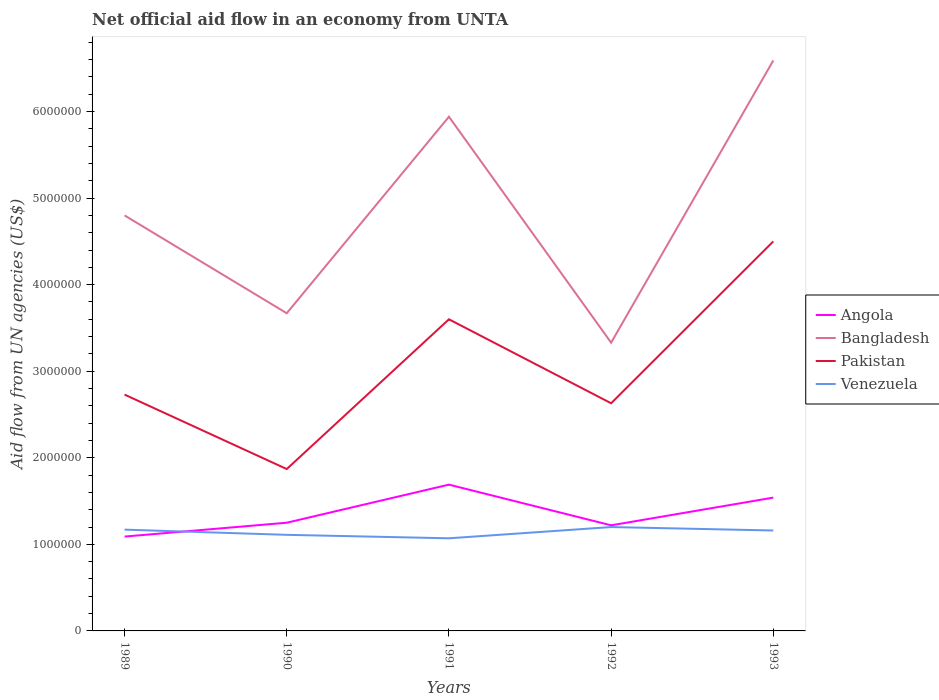Across all years, what is the maximum net official aid flow in Bangladesh?
Offer a terse response. 3.33e+06. In which year was the net official aid flow in Bangladesh maximum?
Keep it short and to the point. 1992. What is the total net official aid flow in Venezuela in the graph?
Make the answer very short. 4.00e+04. What is the difference between the highest and the second highest net official aid flow in Pakistan?
Your answer should be compact. 2.63e+06. What is the difference between the highest and the lowest net official aid flow in Venezuela?
Give a very brief answer. 3. Is the net official aid flow in Bangladesh strictly greater than the net official aid flow in Angola over the years?
Your answer should be very brief. No. How many lines are there?
Your response must be concise. 4. How many years are there in the graph?
Offer a terse response. 5. Does the graph contain any zero values?
Provide a short and direct response. No. Does the graph contain grids?
Ensure brevity in your answer.  No. Where does the legend appear in the graph?
Provide a short and direct response. Center right. What is the title of the graph?
Make the answer very short. Net official aid flow in an economy from UNTA. What is the label or title of the Y-axis?
Make the answer very short. Aid flow from UN agencies (US$). What is the Aid flow from UN agencies (US$) in Angola in 1989?
Provide a short and direct response. 1.09e+06. What is the Aid flow from UN agencies (US$) of Bangladesh in 1989?
Provide a short and direct response. 4.80e+06. What is the Aid flow from UN agencies (US$) in Pakistan in 1989?
Make the answer very short. 2.73e+06. What is the Aid flow from UN agencies (US$) in Venezuela in 1989?
Provide a short and direct response. 1.17e+06. What is the Aid flow from UN agencies (US$) of Angola in 1990?
Give a very brief answer. 1.25e+06. What is the Aid flow from UN agencies (US$) of Bangladesh in 1990?
Give a very brief answer. 3.67e+06. What is the Aid flow from UN agencies (US$) in Pakistan in 1990?
Offer a very short reply. 1.87e+06. What is the Aid flow from UN agencies (US$) of Venezuela in 1990?
Offer a terse response. 1.11e+06. What is the Aid flow from UN agencies (US$) of Angola in 1991?
Keep it short and to the point. 1.69e+06. What is the Aid flow from UN agencies (US$) in Bangladesh in 1991?
Keep it short and to the point. 5.94e+06. What is the Aid flow from UN agencies (US$) in Pakistan in 1991?
Provide a succinct answer. 3.60e+06. What is the Aid flow from UN agencies (US$) of Venezuela in 1991?
Your response must be concise. 1.07e+06. What is the Aid flow from UN agencies (US$) in Angola in 1992?
Provide a short and direct response. 1.22e+06. What is the Aid flow from UN agencies (US$) in Bangladesh in 1992?
Make the answer very short. 3.33e+06. What is the Aid flow from UN agencies (US$) of Pakistan in 1992?
Make the answer very short. 2.63e+06. What is the Aid flow from UN agencies (US$) of Venezuela in 1992?
Your answer should be compact. 1.20e+06. What is the Aid flow from UN agencies (US$) in Angola in 1993?
Give a very brief answer. 1.54e+06. What is the Aid flow from UN agencies (US$) in Bangladesh in 1993?
Your answer should be very brief. 6.59e+06. What is the Aid flow from UN agencies (US$) of Pakistan in 1993?
Your answer should be very brief. 4.50e+06. What is the Aid flow from UN agencies (US$) of Venezuela in 1993?
Provide a short and direct response. 1.16e+06. Across all years, what is the maximum Aid flow from UN agencies (US$) in Angola?
Offer a very short reply. 1.69e+06. Across all years, what is the maximum Aid flow from UN agencies (US$) in Bangladesh?
Provide a short and direct response. 6.59e+06. Across all years, what is the maximum Aid flow from UN agencies (US$) of Pakistan?
Give a very brief answer. 4.50e+06. Across all years, what is the maximum Aid flow from UN agencies (US$) in Venezuela?
Provide a succinct answer. 1.20e+06. Across all years, what is the minimum Aid flow from UN agencies (US$) in Angola?
Ensure brevity in your answer.  1.09e+06. Across all years, what is the minimum Aid flow from UN agencies (US$) of Bangladesh?
Your answer should be compact. 3.33e+06. Across all years, what is the minimum Aid flow from UN agencies (US$) of Pakistan?
Make the answer very short. 1.87e+06. Across all years, what is the minimum Aid flow from UN agencies (US$) of Venezuela?
Your response must be concise. 1.07e+06. What is the total Aid flow from UN agencies (US$) in Angola in the graph?
Give a very brief answer. 6.79e+06. What is the total Aid flow from UN agencies (US$) in Bangladesh in the graph?
Offer a very short reply. 2.43e+07. What is the total Aid flow from UN agencies (US$) in Pakistan in the graph?
Offer a very short reply. 1.53e+07. What is the total Aid flow from UN agencies (US$) of Venezuela in the graph?
Offer a very short reply. 5.71e+06. What is the difference between the Aid flow from UN agencies (US$) of Angola in 1989 and that in 1990?
Provide a succinct answer. -1.60e+05. What is the difference between the Aid flow from UN agencies (US$) of Bangladesh in 1989 and that in 1990?
Keep it short and to the point. 1.13e+06. What is the difference between the Aid flow from UN agencies (US$) in Pakistan in 1989 and that in 1990?
Ensure brevity in your answer.  8.60e+05. What is the difference between the Aid flow from UN agencies (US$) in Angola in 1989 and that in 1991?
Your answer should be very brief. -6.00e+05. What is the difference between the Aid flow from UN agencies (US$) of Bangladesh in 1989 and that in 1991?
Offer a terse response. -1.14e+06. What is the difference between the Aid flow from UN agencies (US$) of Pakistan in 1989 and that in 1991?
Your response must be concise. -8.70e+05. What is the difference between the Aid flow from UN agencies (US$) in Venezuela in 1989 and that in 1991?
Offer a terse response. 1.00e+05. What is the difference between the Aid flow from UN agencies (US$) of Bangladesh in 1989 and that in 1992?
Offer a terse response. 1.47e+06. What is the difference between the Aid flow from UN agencies (US$) in Venezuela in 1989 and that in 1992?
Offer a terse response. -3.00e+04. What is the difference between the Aid flow from UN agencies (US$) of Angola in 1989 and that in 1993?
Keep it short and to the point. -4.50e+05. What is the difference between the Aid flow from UN agencies (US$) in Bangladesh in 1989 and that in 1993?
Keep it short and to the point. -1.79e+06. What is the difference between the Aid flow from UN agencies (US$) of Pakistan in 1989 and that in 1993?
Provide a succinct answer. -1.77e+06. What is the difference between the Aid flow from UN agencies (US$) in Angola in 1990 and that in 1991?
Your answer should be very brief. -4.40e+05. What is the difference between the Aid flow from UN agencies (US$) of Bangladesh in 1990 and that in 1991?
Give a very brief answer. -2.27e+06. What is the difference between the Aid flow from UN agencies (US$) in Pakistan in 1990 and that in 1991?
Your response must be concise. -1.73e+06. What is the difference between the Aid flow from UN agencies (US$) of Bangladesh in 1990 and that in 1992?
Make the answer very short. 3.40e+05. What is the difference between the Aid flow from UN agencies (US$) in Pakistan in 1990 and that in 1992?
Offer a terse response. -7.60e+05. What is the difference between the Aid flow from UN agencies (US$) in Angola in 1990 and that in 1993?
Keep it short and to the point. -2.90e+05. What is the difference between the Aid flow from UN agencies (US$) of Bangladesh in 1990 and that in 1993?
Offer a very short reply. -2.92e+06. What is the difference between the Aid flow from UN agencies (US$) in Pakistan in 1990 and that in 1993?
Your response must be concise. -2.63e+06. What is the difference between the Aid flow from UN agencies (US$) in Venezuela in 1990 and that in 1993?
Give a very brief answer. -5.00e+04. What is the difference between the Aid flow from UN agencies (US$) in Angola in 1991 and that in 1992?
Your answer should be compact. 4.70e+05. What is the difference between the Aid flow from UN agencies (US$) in Bangladesh in 1991 and that in 1992?
Offer a very short reply. 2.61e+06. What is the difference between the Aid flow from UN agencies (US$) of Pakistan in 1991 and that in 1992?
Keep it short and to the point. 9.70e+05. What is the difference between the Aid flow from UN agencies (US$) of Bangladesh in 1991 and that in 1993?
Make the answer very short. -6.50e+05. What is the difference between the Aid flow from UN agencies (US$) in Pakistan in 1991 and that in 1993?
Your response must be concise. -9.00e+05. What is the difference between the Aid flow from UN agencies (US$) of Angola in 1992 and that in 1993?
Offer a very short reply. -3.20e+05. What is the difference between the Aid flow from UN agencies (US$) in Bangladesh in 1992 and that in 1993?
Provide a succinct answer. -3.26e+06. What is the difference between the Aid flow from UN agencies (US$) of Pakistan in 1992 and that in 1993?
Your answer should be compact. -1.87e+06. What is the difference between the Aid flow from UN agencies (US$) in Angola in 1989 and the Aid flow from UN agencies (US$) in Bangladesh in 1990?
Give a very brief answer. -2.58e+06. What is the difference between the Aid flow from UN agencies (US$) in Angola in 1989 and the Aid flow from UN agencies (US$) in Pakistan in 1990?
Offer a terse response. -7.80e+05. What is the difference between the Aid flow from UN agencies (US$) of Bangladesh in 1989 and the Aid flow from UN agencies (US$) of Pakistan in 1990?
Your answer should be compact. 2.93e+06. What is the difference between the Aid flow from UN agencies (US$) of Bangladesh in 1989 and the Aid flow from UN agencies (US$) of Venezuela in 1990?
Ensure brevity in your answer.  3.69e+06. What is the difference between the Aid flow from UN agencies (US$) of Pakistan in 1989 and the Aid flow from UN agencies (US$) of Venezuela in 1990?
Keep it short and to the point. 1.62e+06. What is the difference between the Aid flow from UN agencies (US$) in Angola in 1989 and the Aid flow from UN agencies (US$) in Bangladesh in 1991?
Provide a succinct answer. -4.85e+06. What is the difference between the Aid flow from UN agencies (US$) of Angola in 1989 and the Aid flow from UN agencies (US$) of Pakistan in 1991?
Your response must be concise. -2.51e+06. What is the difference between the Aid flow from UN agencies (US$) of Bangladesh in 1989 and the Aid flow from UN agencies (US$) of Pakistan in 1991?
Provide a short and direct response. 1.20e+06. What is the difference between the Aid flow from UN agencies (US$) of Bangladesh in 1989 and the Aid flow from UN agencies (US$) of Venezuela in 1991?
Your response must be concise. 3.73e+06. What is the difference between the Aid flow from UN agencies (US$) in Pakistan in 1989 and the Aid flow from UN agencies (US$) in Venezuela in 1991?
Make the answer very short. 1.66e+06. What is the difference between the Aid flow from UN agencies (US$) of Angola in 1989 and the Aid flow from UN agencies (US$) of Bangladesh in 1992?
Make the answer very short. -2.24e+06. What is the difference between the Aid flow from UN agencies (US$) in Angola in 1989 and the Aid flow from UN agencies (US$) in Pakistan in 1992?
Provide a short and direct response. -1.54e+06. What is the difference between the Aid flow from UN agencies (US$) in Bangladesh in 1989 and the Aid flow from UN agencies (US$) in Pakistan in 1992?
Your response must be concise. 2.17e+06. What is the difference between the Aid flow from UN agencies (US$) of Bangladesh in 1989 and the Aid flow from UN agencies (US$) of Venezuela in 1992?
Your answer should be very brief. 3.60e+06. What is the difference between the Aid flow from UN agencies (US$) of Pakistan in 1989 and the Aid flow from UN agencies (US$) of Venezuela in 1992?
Your response must be concise. 1.53e+06. What is the difference between the Aid flow from UN agencies (US$) of Angola in 1989 and the Aid flow from UN agencies (US$) of Bangladesh in 1993?
Ensure brevity in your answer.  -5.50e+06. What is the difference between the Aid flow from UN agencies (US$) of Angola in 1989 and the Aid flow from UN agencies (US$) of Pakistan in 1993?
Keep it short and to the point. -3.41e+06. What is the difference between the Aid flow from UN agencies (US$) of Angola in 1989 and the Aid flow from UN agencies (US$) of Venezuela in 1993?
Offer a terse response. -7.00e+04. What is the difference between the Aid flow from UN agencies (US$) in Bangladesh in 1989 and the Aid flow from UN agencies (US$) in Venezuela in 1993?
Ensure brevity in your answer.  3.64e+06. What is the difference between the Aid flow from UN agencies (US$) in Pakistan in 1989 and the Aid flow from UN agencies (US$) in Venezuela in 1993?
Ensure brevity in your answer.  1.57e+06. What is the difference between the Aid flow from UN agencies (US$) in Angola in 1990 and the Aid flow from UN agencies (US$) in Bangladesh in 1991?
Your answer should be very brief. -4.69e+06. What is the difference between the Aid flow from UN agencies (US$) of Angola in 1990 and the Aid flow from UN agencies (US$) of Pakistan in 1991?
Your response must be concise. -2.35e+06. What is the difference between the Aid flow from UN agencies (US$) in Bangladesh in 1990 and the Aid flow from UN agencies (US$) in Venezuela in 1991?
Offer a very short reply. 2.60e+06. What is the difference between the Aid flow from UN agencies (US$) of Angola in 1990 and the Aid flow from UN agencies (US$) of Bangladesh in 1992?
Ensure brevity in your answer.  -2.08e+06. What is the difference between the Aid flow from UN agencies (US$) of Angola in 1990 and the Aid flow from UN agencies (US$) of Pakistan in 1992?
Keep it short and to the point. -1.38e+06. What is the difference between the Aid flow from UN agencies (US$) of Angola in 1990 and the Aid flow from UN agencies (US$) of Venezuela in 1992?
Offer a very short reply. 5.00e+04. What is the difference between the Aid flow from UN agencies (US$) of Bangladesh in 1990 and the Aid flow from UN agencies (US$) of Pakistan in 1992?
Offer a terse response. 1.04e+06. What is the difference between the Aid flow from UN agencies (US$) of Bangladesh in 1990 and the Aid flow from UN agencies (US$) of Venezuela in 1992?
Your answer should be very brief. 2.47e+06. What is the difference between the Aid flow from UN agencies (US$) of Pakistan in 1990 and the Aid flow from UN agencies (US$) of Venezuela in 1992?
Make the answer very short. 6.70e+05. What is the difference between the Aid flow from UN agencies (US$) in Angola in 1990 and the Aid flow from UN agencies (US$) in Bangladesh in 1993?
Provide a short and direct response. -5.34e+06. What is the difference between the Aid flow from UN agencies (US$) in Angola in 1990 and the Aid flow from UN agencies (US$) in Pakistan in 1993?
Keep it short and to the point. -3.25e+06. What is the difference between the Aid flow from UN agencies (US$) of Angola in 1990 and the Aid flow from UN agencies (US$) of Venezuela in 1993?
Provide a succinct answer. 9.00e+04. What is the difference between the Aid flow from UN agencies (US$) of Bangladesh in 1990 and the Aid flow from UN agencies (US$) of Pakistan in 1993?
Ensure brevity in your answer.  -8.30e+05. What is the difference between the Aid flow from UN agencies (US$) in Bangladesh in 1990 and the Aid flow from UN agencies (US$) in Venezuela in 1993?
Keep it short and to the point. 2.51e+06. What is the difference between the Aid flow from UN agencies (US$) in Pakistan in 1990 and the Aid flow from UN agencies (US$) in Venezuela in 1993?
Your answer should be very brief. 7.10e+05. What is the difference between the Aid flow from UN agencies (US$) in Angola in 1991 and the Aid flow from UN agencies (US$) in Bangladesh in 1992?
Your answer should be very brief. -1.64e+06. What is the difference between the Aid flow from UN agencies (US$) in Angola in 1991 and the Aid flow from UN agencies (US$) in Pakistan in 1992?
Make the answer very short. -9.40e+05. What is the difference between the Aid flow from UN agencies (US$) in Bangladesh in 1991 and the Aid flow from UN agencies (US$) in Pakistan in 1992?
Make the answer very short. 3.31e+06. What is the difference between the Aid flow from UN agencies (US$) of Bangladesh in 1991 and the Aid flow from UN agencies (US$) of Venezuela in 1992?
Offer a very short reply. 4.74e+06. What is the difference between the Aid flow from UN agencies (US$) of Pakistan in 1991 and the Aid flow from UN agencies (US$) of Venezuela in 1992?
Give a very brief answer. 2.40e+06. What is the difference between the Aid flow from UN agencies (US$) in Angola in 1991 and the Aid flow from UN agencies (US$) in Bangladesh in 1993?
Offer a terse response. -4.90e+06. What is the difference between the Aid flow from UN agencies (US$) in Angola in 1991 and the Aid flow from UN agencies (US$) in Pakistan in 1993?
Provide a short and direct response. -2.81e+06. What is the difference between the Aid flow from UN agencies (US$) of Angola in 1991 and the Aid flow from UN agencies (US$) of Venezuela in 1993?
Ensure brevity in your answer.  5.30e+05. What is the difference between the Aid flow from UN agencies (US$) of Bangladesh in 1991 and the Aid flow from UN agencies (US$) of Pakistan in 1993?
Provide a short and direct response. 1.44e+06. What is the difference between the Aid flow from UN agencies (US$) of Bangladesh in 1991 and the Aid flow from UN agencies (US$) of Venezuela in 1993?
Keep it short and to the point. 4.78e+06. What is the difference between the Aid flow from UN agencies (US$) of Pakistan in 1991 and the Aid flow from UN agencies (US$) of Venezuela in 1993?
Offer a very short reply. 2.44e+06. What is the difference between the Aid flow from UN agencies (US$) of Angola in 1992 and the Aid flow from UN agencies (US$) of Bangladesh in 1993?
Your answer should be very brief. -5.37e+06. What is the difference between the Aid flow from UN agencies (US$) of Angola in 1992 and the Aid flow from UN agencies (US$) of Pakistan in 1993?
Offer a terse response. -3.28e+06. What is the difference between the Aid flow from UN agencies (US$) in Angola in 1992 and the Aid flow from UN agencies (US$) in Venezuela in 1993?
Give a very brief answer. 6.00e+04. What is the difference between the Aid flow from UN agencies (US$) in Bangladesh in 1992 and the Aid flow from UN agencies (US$) in Pakistan in 1993?
Your response must be concise. -1.17e+06. What is the difference between the Aid flow from UN agencies (US$) of Bangladesh in 1992 and the Aid flow from UN agencies (US$) of Venezuela in 1993?
Provide a succinct answer. 2.17e+06. What is the difference between the Aid flow from UN agencies (US$) of Pakistan in 1992 and the Aid flow from UN agencies (US$) of Venezuela in 1993?
Your response must be concise. 1.47e+06. What is the average Aid flow from UN agencies (US$) in Angola per year?
Your answer should be compact. 1.36e+06. What is the average Aid flow from UN agencies (US$) in Bangladesh per year?
Offer a very short reply. 4.87e+06. What is the average Aid flow from UN agencies (US$) in Pakistan per year?
Your answer should be compact. 3.07e+06. What is the average Aid flow from UN agencies (US$) of Venezuela per year?
Ensure brevity in your answer.  1.14e+06. In the year 1989, what is the difference between the Aid flow from UN agencies (US$) in Angola and Aid flow from UN agencies (US$) in Bangladesh?
Give a very brief answer. -3.71e+06. In the year 1989, what is the difference between the Aid flow from UN agencies (US$) in Angola and Aid flow from UN agencies (US$) in Pakistan?
Make the answer very short. -1.64e+06. In the year 1989, what is the difference between the Aid flow from UN agencies (US$) in Angola and Aid flow from UN agencies (US$) in Venezuela?
Your answer should be compact. -8.00e+04. In the year 1989, what is the difference between the Aid flow from UN agencies (US$) of Bangladesh and Aid flow from UN agencies (US$) of Pakistan?
Offer a very short reply. 2.07e+06. In the year 1989, what is the difference between the Aid flow from UN agencies (US$) of Bangladesh and Aid flow from UN agencies (US$) of Venezuela?
Provide a short and direct response. 3.63e+06. In the year 1989, what is the difference between the Aid flow from UN agencies (US$) of Pakistan and Aid flow from UN agencies (US$) of Venezuela?
Your answer should be compact. 1.56e+06. In the year 1990, what is the difference between the Aid flow from UN agencies (US$) in Angola and Aid flow from UN agencies (US$) in Bangladesh?
Make the answer very short. -2.42e+06. In the year 1990, what is the difference between the Aid flow from UN agencies (US$) of Angola and Aid flow from UN agencies (US$) of Pakistan?
Offer a terse response. -6.20e+05. In the year 1990, what is the difference between the Aid flow from UN agencies (US$) in Bangladesh and Aid flow from UN agencies (US$) in Pakistan?
Keep it short and to the point. 1.80e+06. In the year 1990, what is the difference between the Aid flow from UN agencies (US$) of Bangladesh and Aid flow from UN agencies (US$) of Venezuela?
Provide a succinct answer. 2.56e+06. In the year 1990, what is the difference between the Aid flow from UN agencies (US$) of Pakistan and Aid flow from UN agencies (US$) of Venezuela?
Provide a short and direct response. 7.60e+05. In the year 1991, what is the difference between the Aid flow from UN agencies (US$) in Angola and Aid flow from UN agencies (US$) in Bangladesh?
Make the answer very short. -4.25e+06. In the year 1991, what is the difference between the Aid flow from UN agencies (US$) in Angola and Aid flow from UN agencies (US$) in Pakistan?
Provide a short and direct response. -1.91e+06. In the year 1991, what is the difference between the Aid flow from UN agencies (US$) in Angola and Aid flow from UN agencies (US$) in Venezuela?
Give a very brief answer. 6.20e+05. In the year 1991, what is the difference between the Aid flow from UN agencies (US$) of Bangladesh and Aid flow from UN agencies (US$) of Pakistan?
Make the answer very short. 2.34e+06. In the year 1991, what is the difference between the Aid flow from UN agencies (US$) in Bangladesh and Aid flow from UN agencies (US$) in Venezuela?
Provide a succinct answer. 4.87e+06. In the year 1991, what is the difference between the Aid flow from UN agencies (US$) in Pakistan and Aid flow from UN agencies (US$) in Venezuela?
Keep it short and to the point. 2.53e+06. In the year 1992, what is the difference between the Aid flow from UN agencies (US$) of Angola and Aid flow from UN agencies (US$) of Bangladesh?
Keep it short and to the point. -2.11e+06. In the year 1992, what is the difference between the Aid flow from UN agencies (US$) of Angola and Aid flow from UN agencies (US$) of Pakistan?
Make the answer very short. -1.41e+06. In the year 1992, what is the difference between the Aid flow from UN agencies (US$) in Bangladesh and Aid flow from UN agencies (US$) in Venezuela?
Provide a succinct answer. 2.13e+06. In the year 1992, what is the difference between the Aid flow from UN agencies (US$) of Pakistan and Aid flow from UN agencies (US$) of Venezuela?
Provide a short and direct response. 1.43e+06. In the year 1993, what is the difference between the Aid flow from UN agencies (US$) in Angola and Aid flow from UN agencies (US$) in Bangladesh?
Provide a succinct answer. -5.05e+06. In the year 1993, what is the difference between the Aid flow from UN agencies (US$) in Angola and Aid flow from UN agencies (US$) in Pakistan?
Provide a succinct answer. -2.96e+06. In the year 1993, what is the difference between the Aid flow from UN agencies (US$) in Angola and Aid flow from UN agencies (US$) in Venezuela?
Your response must be concise. 3.80e+05. In the year 1993, what is the difference between the Aid flow from UN agencies (US$) in Bangladesh and Aid flow from UN agencies (US$) in Pakistan?
Your answer should be compact. 2.09e+06. In the year 1993, what is the difference between the Aid flow from UN agencies (US$) in Bangladesh and Aid flow from UN agencies (US$) in Venezuela?
Provide a succinct answer. 5.43e+06. In the year 1993, what is the difference between the Aid flow from UN agencies (US$) in Pakistan and Aid flow from UN agencies (US$) in Venezuela?
Give a very brief answer. 3.34e+06. What is the ratio of the Aid flow from UN agencies (US$) in Angola in 1989 to that in 1990?
Ensure brevity in your answer.  0.87. What is the ratio of the Aid flow from UN agencies (US$) of Bangladesh in 1989 to that in 1990?
Ensure brevity in your answer.  1.31. What is the ratio of the Aid flow from UN agencies (US$) in Pakistan in 1989 to that in 1990?
Offer a very short reply. 1.46. What is the ratio of the Aid flow from UN agencies (US$) of Venezuela in 1989 to that in 1990?
Keep it short and to the point. 1.05. What is the ratio of the Aid flow from UN agencies (US$) in Angola in 1989 to that in 1991?
Ensure brevity in your answer.  0.65. What is the ratio of the Aid flow from UN agencies (US$) of Bangladesh in 1989 to that in 1991?
Your answer should be very brief. 0.81. What is the ratio of the Aid flow from UN agencies (US$) in Pakistan in 1989 to that in 1991?
Your answer should be compact. 0.76. What is the ratio of the Aid flow from UN agencies (US$) of Venezuela in 1989 to that in 1991?
Your answer should be very brief. 1.09. What is the ratio of the Aid flow from UN agencies (US$) in Angola in 1989 to that in 1992?
Offer a terse response. 0.89. What is the ratio of the Aid flow from UN agencies (US$) of Bangladesh in 1989 to that in 1992?
Keep it short and to the point. 1.44. What is the ratio of the Aid flow from UN agencies (US$) in Pakistan in 1989 to that in 1992?
Offer a terse response. 1.04. What is the ratio of the Aid flow from UN agencies (US$) of Venezuela in 1989 to that in 1992?
Your answer should be compact. 0.97. What is the ratio of the Aid flow from UN agencies (US$) of Angola in 1989 to that in 1993?
Your response must be concise. 0.71. What is the ratio of the Aid flow from UN agencies (US$) in Bangladesh in 1989 to that in 1993?
Offer a terse response. 0.73. What is the ratio of the Aid flow from UN agencies (US$) in Pakistan in 1989 to that in 1993?
Your answer should be compact. 0.61. What is the ratio of the Aid flow from UN agencies (US$) of Venezuela in 1989 to that in 1993?
Ensure brevity in your answer.  1.01. What is the ratio of the Aid flow from UN agencies (US$) of Angola in 1990 to that in 1991?
Your response must be concise. 0.74. What is the ratio of the Aid flow from UN agencies (US$) of Bangladesh in 1990 to that in 1991?
Your answer should be compact. 0.62. What is the ratio of the Aid flow from UN agencies (US$) in Pakistan in 1990 to that in 1991?
Keep it short and to the point. 0.52. What is the ratio of the Aid flow from UN agencies (US$) of Venezuela in 1990 to that in 1991?
Keep it short and to the point. 1.04. What is the ratio of the Aid flow from UN agencies (US$) of Angola in 1990 to that in 1992?
Your response must be concise. 1.02. What is the ratio of the Aid flow from UN agencies (US$) of Bangladesh in 1990 to that in 1992?
Keep it short and to the point. 1.1. What is the ratio of the Aid flow from UN agencies (US$) in Pakistan in 1990 to that in 1992?
Provide a succinct answer. 0.71. What is the ratio of the Aid flow from UN agencies (US$) of Venezuela in 1990 to that in 1992?
Your answer should be compact. 0.93. What is the ratio of the Aid flow from UN agencies (US$) of Angola in 1990 to that in 1993?
Your response must be concise. 0.81. What is the ratio of the Aid flow from UN agencies (US$) of Bangladesh in 1990 to that in 1993?
Keep it short and to the point. 0.56. What is the ratio of the Aid flow from UN agencies (US$) of Pakistan in 1990 to that in 1993?
Provide a succinct answer. 0.42. What is the ratio of the Aid flow from UN agencies (US$) of Venezuela in 1990 to that in 1993?
Ensure brevity in your answer.  0.96. What is the ratio of the Aid flow from UN agencies (US$) of Angola in 1991 to that in 1992?
Offer a terse response. 1.39. What is the ratio of the Aid flow from UN agencies (US$) of Bangladesh in 1991 to that in 1992?
Keep it short and to the point. 1.78. What is the ratio of the Aid flow from UN agencies (US$) of Pakistan in 1991 to that in 1992?
Keep it short and to the point. 1.37. What is the ratio of the Aid flow from UN agencies (US$) in Venezuela in 1991 to that in 1992?
Offer a very short reply. 0.89. What is the ratio of the Aid flow from UN agencies (US$) of Angola in 1991 to that in 1993?
Your answer should be compact. 1.1. What is the ratio of the Aid flow from UN agencies (US$) in Bangladesh in 1991 to that in 1993?
Make the answer very short. 0.9. What is the ratio of the Aid flow from UN agencies (US$) in Pakistan in 1991 to that in 1993?
Offer a very short reply. 0.8. What is the ratio of the Aid flow from UN agencies (US$) in Venezuela in 1991 to that in 1993?
Your response must be concise. 0.92. What is the ratio of the Aid flow from UN agencies (US$) in Angola in 1992 to that in 1993?
Make the answer very short. 0.79. What is the ratio of the Aid flow from UN agencies (US$) in Bangladesh in 1992 to that in 1993?
Your response must be concise. 0.51. What is the ratio of the Aid flow from UN agencies (US$) in Pakistan in 1992 to that in 1993?
Give a very brief answer. 0.58. What is the ratio of the Aid flow from UN agencies (US$) in Venezuela in 1992 to that in 1993?
Your response must be concise. 1.03. What is the difference between the highest and the second highest Aid flow from UN agencies (US$) of Angola?
Your response must be concise. 1.50e+05. What is the difference between the highest and the second highest Aid flow from UN agencies (US$) in Bangladesh?
Give a very brief answer. 6.50e+05. What is the difference between the highest and the second highest Aid flow from UN agencies (US$) in Pakistan?
Provide a short and direct response. 9.00e+05. What is the difference between the highest and the second highest Aid flow from UN agencies (US$) in Venezuela?
Make the answer very short. 3.00e+04. What is the difference between the highest and the lowest Aid flow from UN agencies (US$) of Angola?
Your answer should be compact. 6.00e+05. What is the difference between the highest and the lowest Aid flow from UN agencies (US$) of Bangladesh?
Provide a succinct answer. 3.26e+06. What is the difference between the highest and the lowest Aid flow from UN agencies (US$) in Pakistan?
Give a very brief answer. 2.63e+06. 